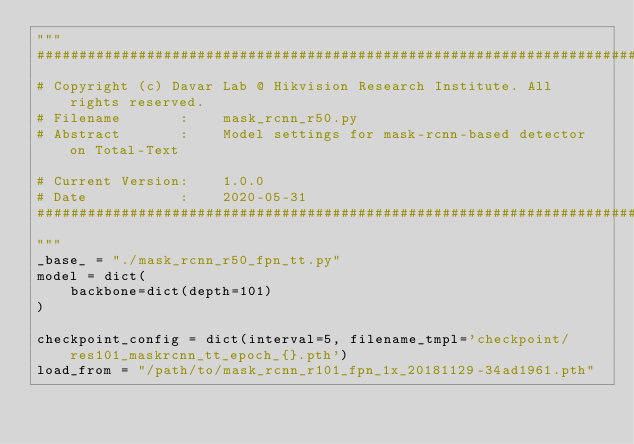Convert code to text. <code><loc_0><loc_0><loc_500><loc_500><_Python_>"""
#########################################################################
# Copyright (c) Davar Lab @ Hikvision Research Institute. All rights reserved.
# Filename       :    mask_rcnn_r50.py
# Abstract       :    Model settings for mask-rcnn-based detector on Total-Text

# Current Version:    1.0.0
# Date           :    2020-05-31
#########################################################################
"""
_base_ = "./mask_rcnn_r50_fpn_tt.py"
model = dict(
    backbone=dict(depth=101)
)

checkpoint_config = dict(interval=5, filename_tmpl='checkpoint/res101_maskrcnn_tt_epoch_{}.pth')
load_from = "/path/to/mask_rcnn_r101_fpn_1x_20181129-34ad1961.pth"

</code> 